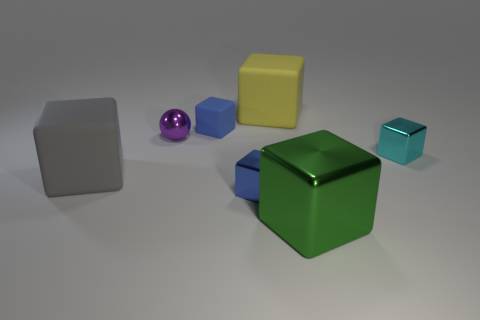Subtract all yellow matte blocks. How many blocks are left? 5 Subtract all red balls. How many blue cubes are left? 2 Add 2 cubes. How many objects exist? 9 Subtract all cyan blocks. How many blocks are left? 5 Subtract 3 blocks. How many blocks are left? 3 Subtract all balls. How many objects are left? 6 Subtract all yellow spheres. Subtract all gray cubes. How many spheres are left? 1 Subtract all small metal blocks. Subtract all large green metal things. How many objects are left? 4 Add 1 tiny purple metal things. How many tiny purple metal things are left? 2 Add 5 big rubber things. How many big rubber things exist? 7 